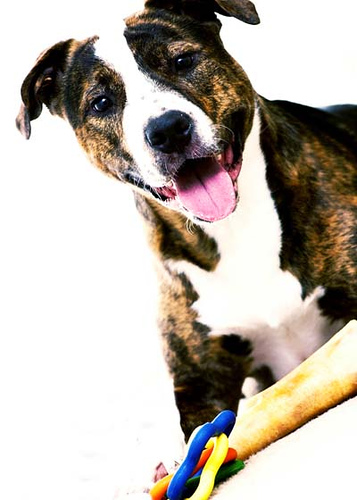<image>
Can you confirm if the dog is behind the bone? Yes. From this viewpoint, the dog is positioned behind the bone, with the bone partially or fully occluding the dog. 